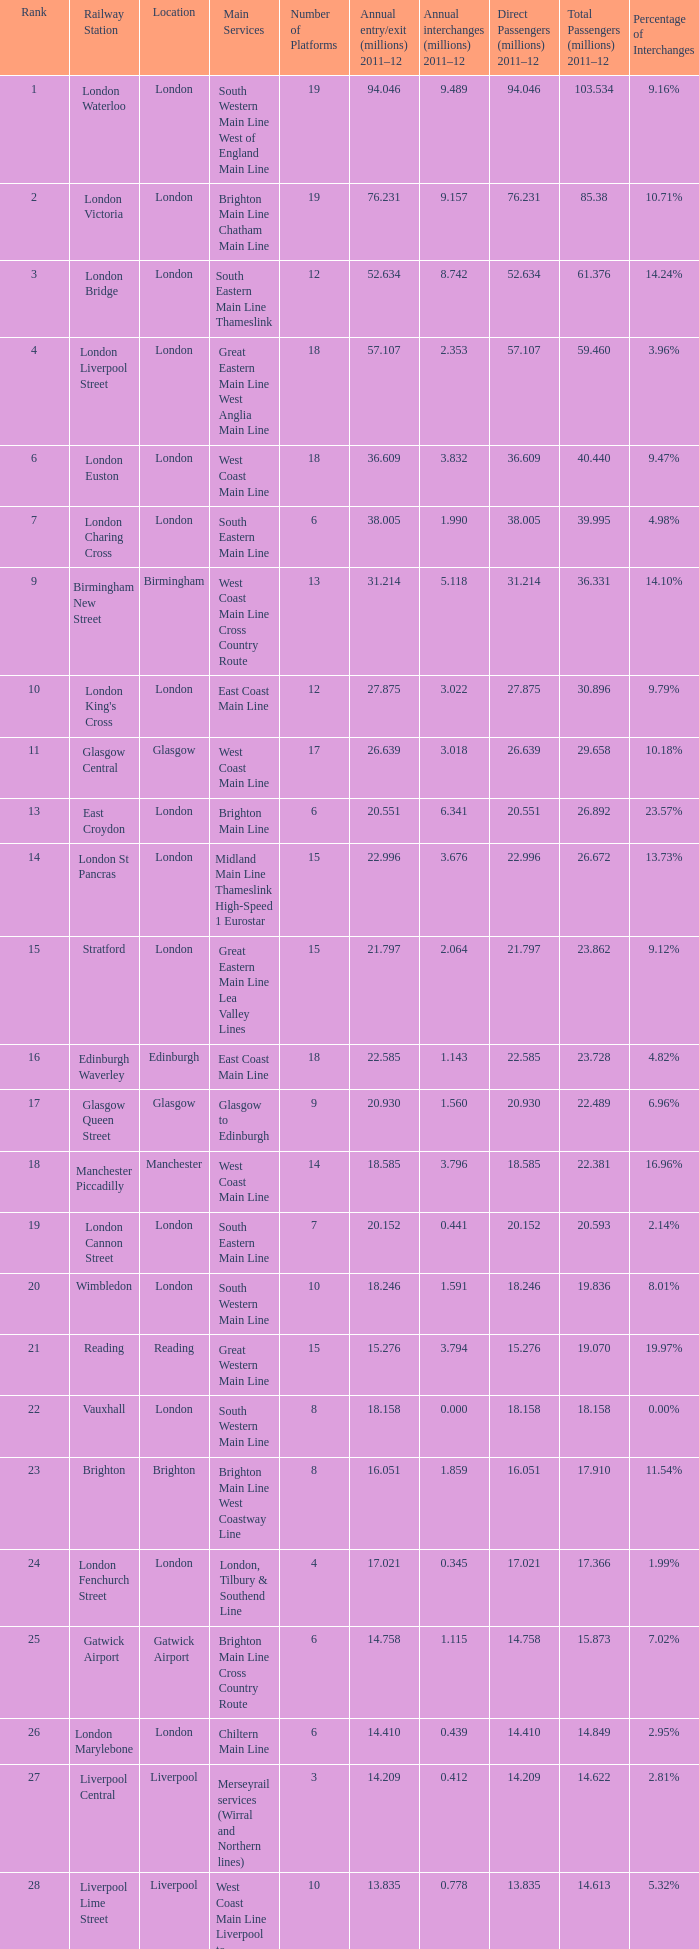What is the main service for the station with 14.849 million passengers 2011-12?  Chiltern Main Line. 